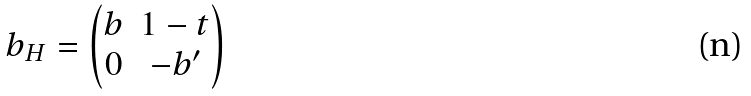Convert formula to latex. <formula><loc_0><loc_0><loc_500><loc_500>b _ { H } = \begin{pmatrix} b & 1 - t \\ 0 & - b ^ { \prime } \end{pmatrix}</formula> 